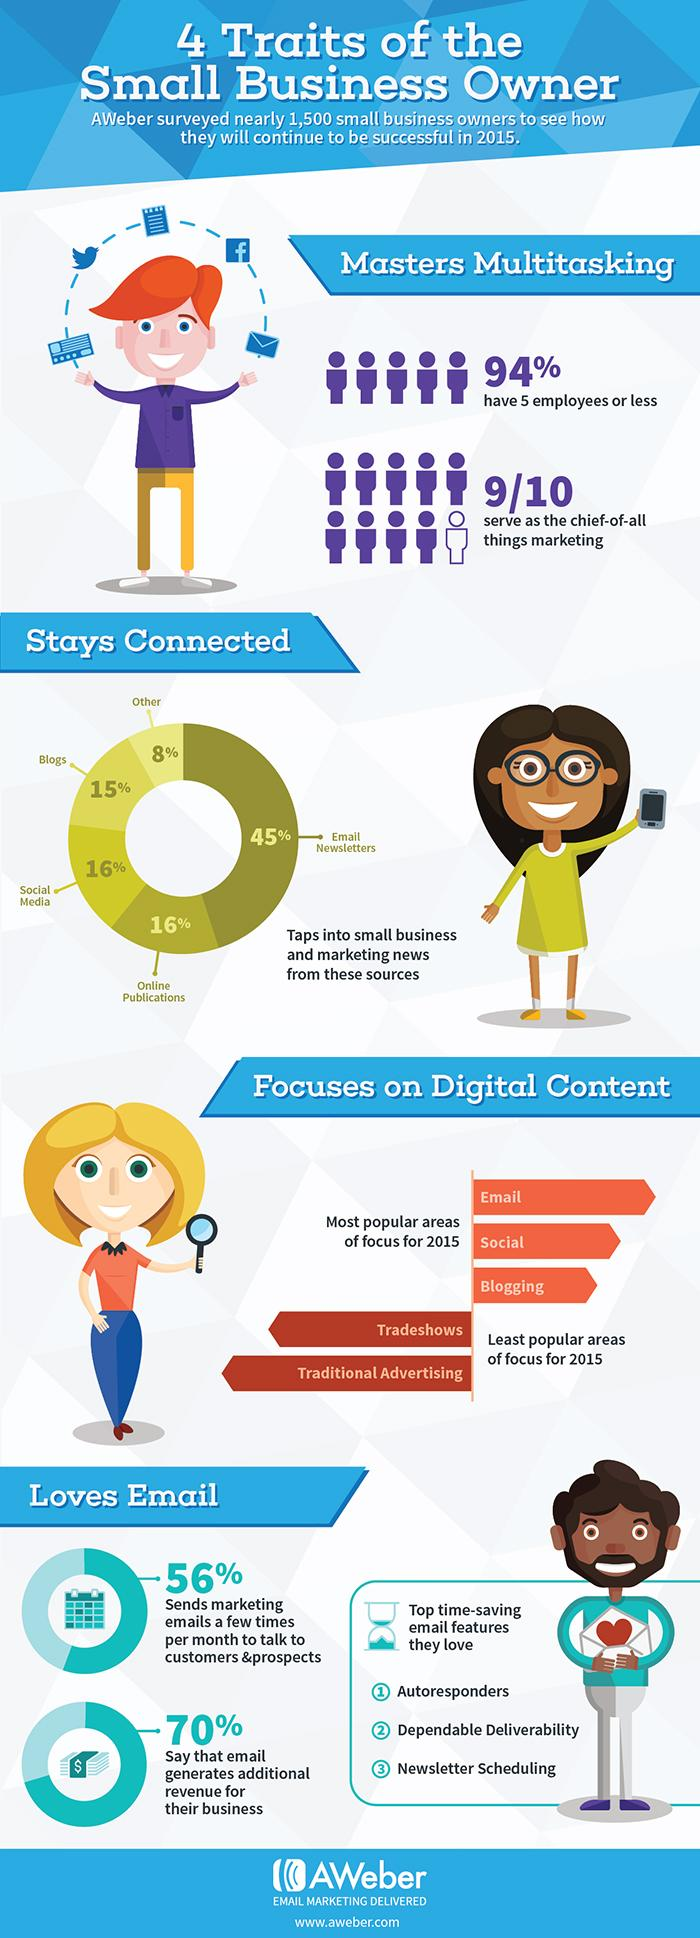Identify some key points in this picture. Ninety percent of all marketing efforts serve as the chief of all things marketing. According to a survey, 70% of people believe that email generates additional revenue. Blogs and social media play a significant role in maintaining connections. People love the time-saving attribute of autoresponders in emails. What percentage of companies with more than 5 employees has more than 5 employees? 